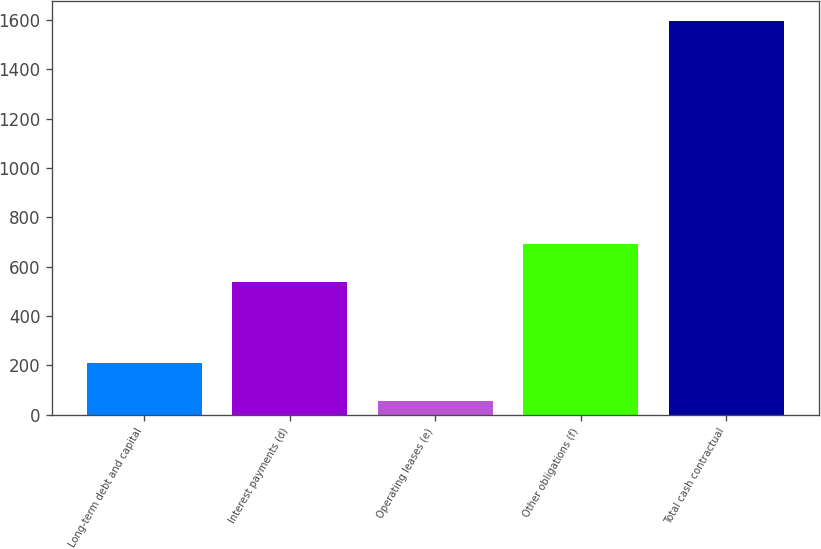Convert chart to OTSL. <chart><loc_0><loc_0><loc_500><loc_500><bar_chart><fcel>Long-term debt and capital<fcel>Interest payments (d)<fcel>Operating leases (e)<fcel>Other obligations (f)<fcel>Total cash contractual<nl><fcel>210.9<fcel>537<fcel>57<fcel>690.9<fcel>1596<nl></chart> 